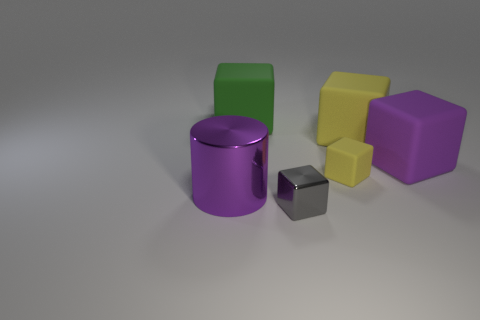Subtract all green cubes. How many cubes are left? 4 Subtract all purple blocks. How many blocks are left? 4 Subtract all red cubes. Subtract all brown balls. How many cubes are left? 5 Add 1 yellow matte spheres. How many objects exist? 7 Subtract all blocks. How many objects are left? 1 Add 2 large metal cylinders. How many large metal cylinders exist? 3 Subtract 0 blue blocks. How many objects are left? 6 Subtract all green matte objects. Subtract all big gray metal cylinders. How many objects are left? 5 Add 4 shiny cylinders. How many shiny cylinders are left? 5 